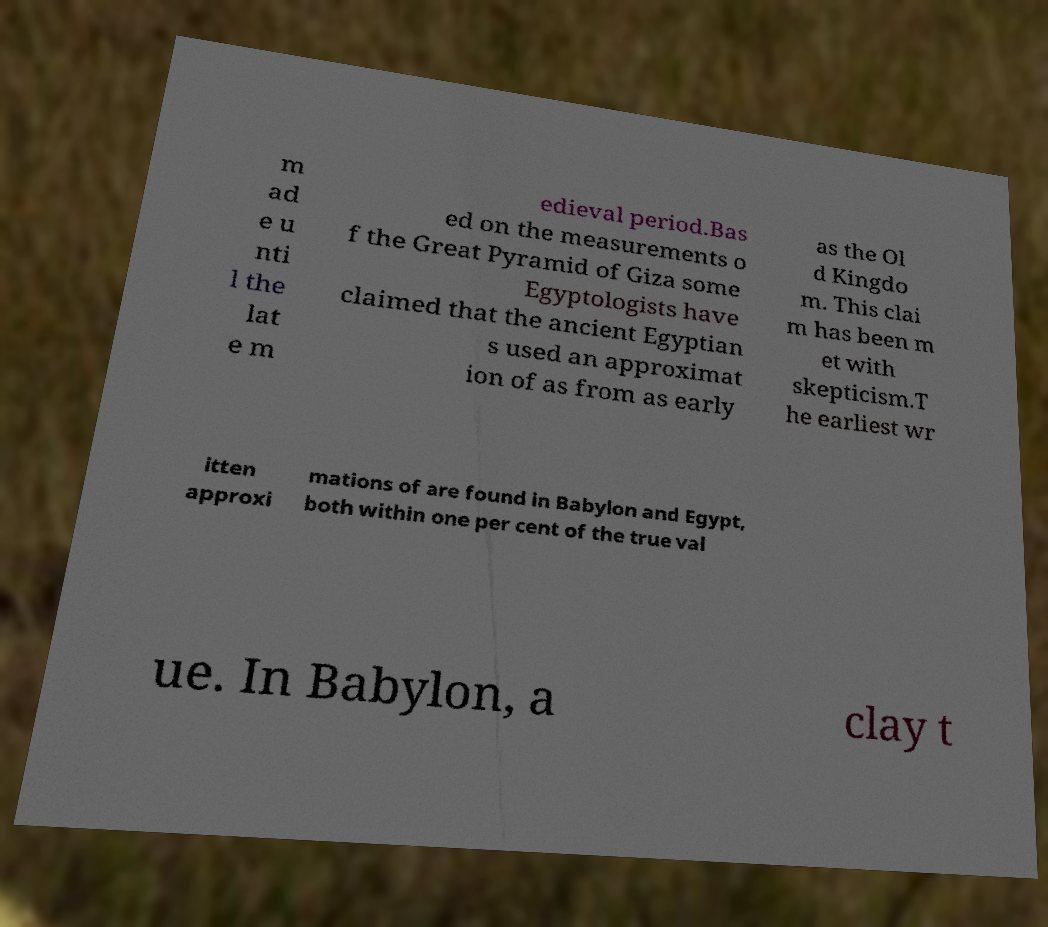Can you accurately transcribe the text from the provided image for me? m ad e u nti l the lat e m edieval period.Bas ed on the measurements o f the Great Pyramid of Giza some Egyptologists have claimed that the ancient Egyptian s used an approximat ion of as from as early as the Ol d Kingdo m. This clai m has been m et with skepticism.T he earliest wr itten approxi mations of are found in Babylon and Egypt, both within one per cent of the true val ue. In Babylon, a clay t 